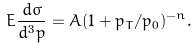<formula> <loc_0><loc_0><loc_500><loc_500>E \frac { d \sigma } { d ^ { 3 } p } = A ( 1 + p _ { T } / p _ { 0 } ) ^ { - n } .</formula> 